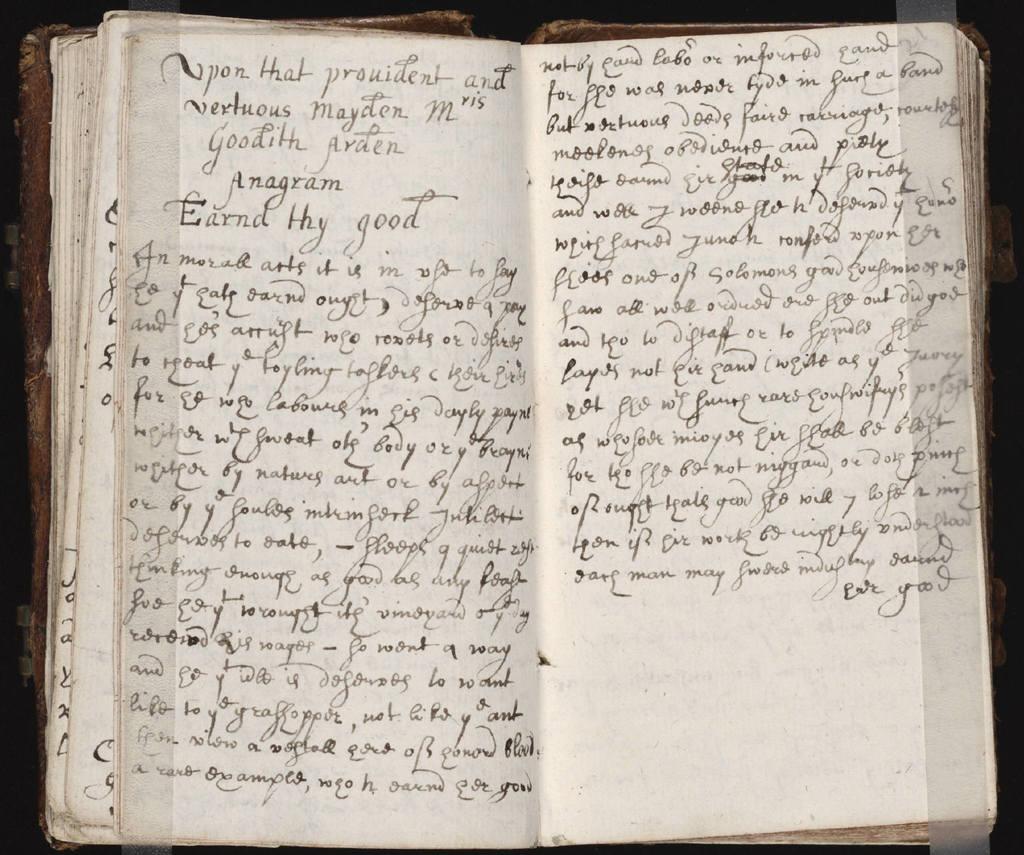What is the first word on the left page?
Offer a very short reply. Upon. 